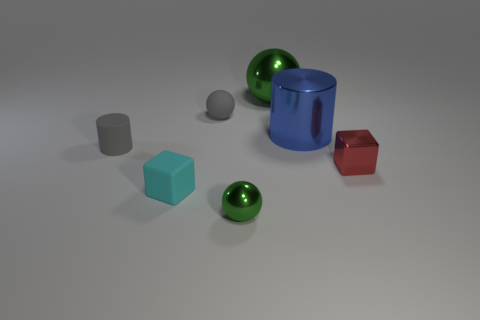What shape is the rubber object that is the same color as the small matte cylinder?
Your answer should be very brief. Sphere. How many cylinders are tiny cyan rubber things or big blue metallic objects?
Keep it short and to the point. 1. Are there an equal number of red metallic things in front of the small green sphere and large green shiny objects that are to the left of the cyan object?
Provide a short and direct response. Yes. What size is the red thing that is the same shape as the cyan object?
Make the answer very short. Small. What is the size of the thing that is both behind the small green ball and in front of the red metal cube?
Make the answer very short. Small. There is a large blue shiny object; are there any cyan blocks to the left of it?
Your response must be concise. Yes. How many objects are either things left of the gray rubber ball or rubber balls?
Provide a short and direct response. 3. There is a cube that is in front of the small red cube; how many big blue cylinders are on the right side of it?
Your response must be concise. 1. Is the number of tiny things behind the tiny red block less than the number of cylinders behind the blue shiny thing?
Provide a succinct answer. No. The gray thing on the left side of the matte thing that is right of the small cyan matte block is what shape?
Offer a very short reply. Cylinder. 